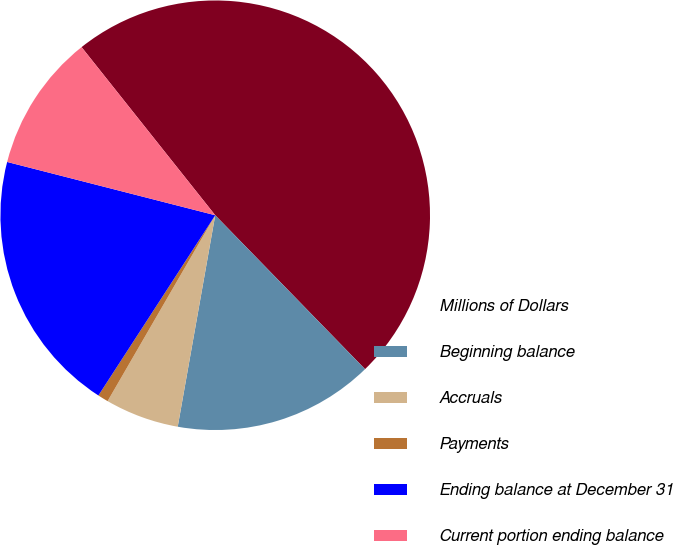Convert chart. <chart><loc_0><loc_0><loc_500><loc_500><pie_chart><fcel>Millions of Dollars<fcel>Beginning balance<fcel>Accruals<fcel>Payments<fcel>Ending balance at December 31<fcel>Current portion ending balance<nl><fcel>48.41%<fcel>15.08%<fcel>5.56%<fcel>0.8%<fcel>19.84%<fcel>10.32%<nl></chart> 